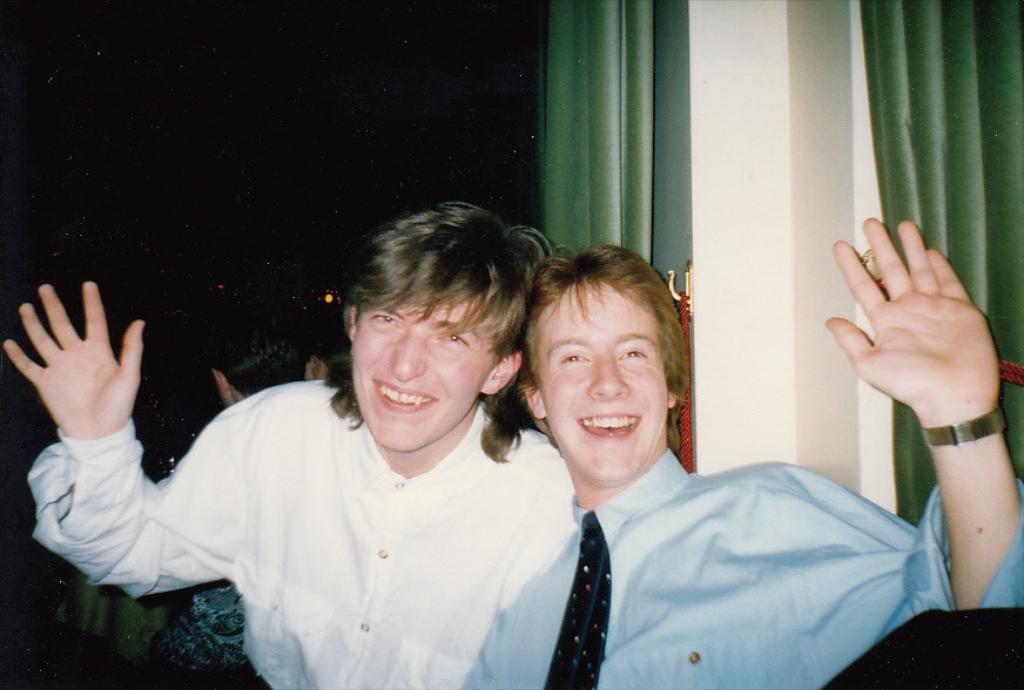Describe this image in one or two sentences. In this image I can see two persons smiling. Behind them I can see the wall, the curtains which are green in color, a person and the dark background. 